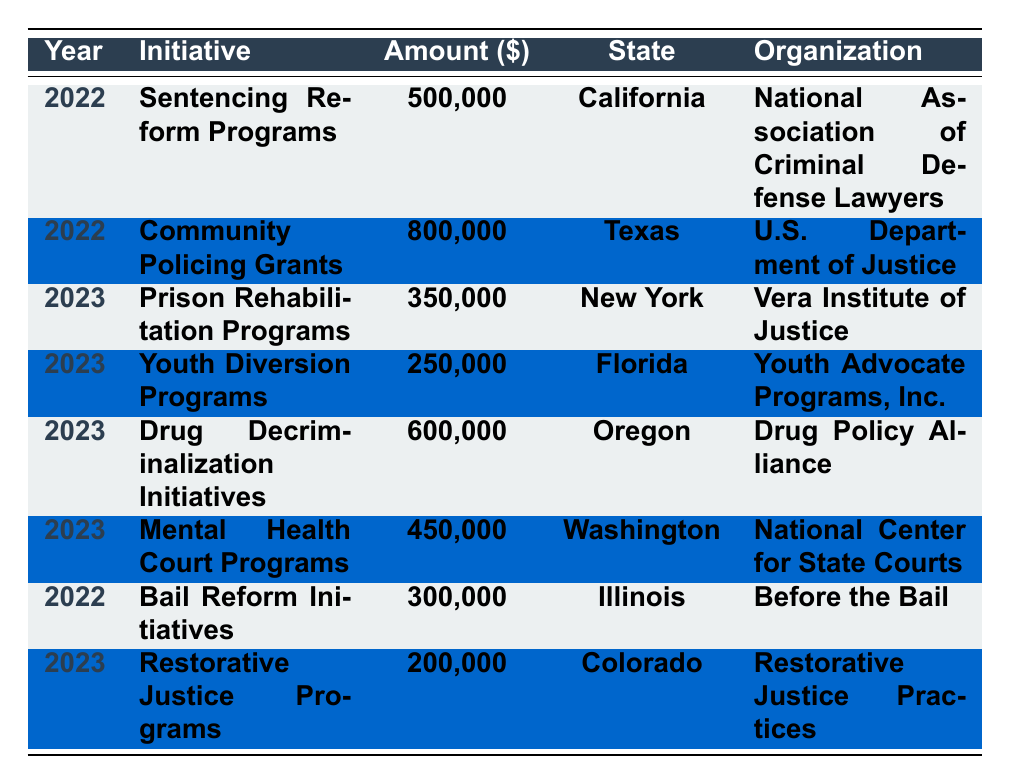What initiative received the highest amount allocated in 2022? The table shows the allocations for each initiative in 2022. The highest amount allocated is for "Community Policing Grants" with $800,000.
Answer: Community Policing Grants How much funding was allocated for Youth Diversion Programs in 2023? The table indicates that "Youth Diversion Programs" received $250,000 allocated in 2023.
Answer: $250,000 Which state received funding for Mental Health Court Programs? According to the table, "Mental Health Court Programs" received funding in Washington state.
Answer: Washington What is the total amount allocated for initiatives in 2023? To find the total for 2023, add the amounts: 350,000 (Prison Rehabilitation) + 250,000 (Youth Diversion) + 600,000 (Drug Decriminalization) + 450,000 (Mental Health Court) + 200,000 (Restorative Justice) = 1,850,000.
Answer: $1,850,000 Did any organization receive funding for more than one initiative in the table? Inspecting the table shows that each organization is listed for only one initiative, thus the answer is no.
Answer: No Which organization received the lowest funding in the table? The funding amounts listed show that "Restorative Justice Programs" received the lowest allocation of $200,000.
Answer: Restorative Justice Practices What is the difference in the amount allocated between the highest and lowest funded initiatives in 2022? The highest funded initiative in 2022 is "Community Policing Grants" ($800,000) and the lowest is "Bail Reform Initiatives" ($300,000). The difference is $800,000 - $300,000 = $500,000.
Answer: $500,000 How many initiatives were funded in California? The table indicates there are two initiatives funded in California: "Sentencing Reform Programs" and "Community Policing Grants."
Answer: 2 What percentage of the total funding in 2022 was allocated to "Sentencing Reform Programs"? In 2022, the total funding is $800,000 (Community Policing Grants) + $500,000 (Sentencing Reform Programs) + $300,000 (Bail Reform Initiatives) = $1,600,000. The percentage for "Sentencing Reform Programs" is ($500,000 / $1,600,000) * 100 = 31.25%.
Answer: 31.25% If you combine the allocations for both years, which state's total funding is the highest? By summing the allocations per state: California = $500,000 + 0 = $500,000; Texas = $800,000; New York = $350,000; Florida = $250,000; Oregon = $600,000; Washington = $450,000; Illinois = $300,000; Colorado = $200,000. Texas has the highest total with $800,000.
Answer: Texas 